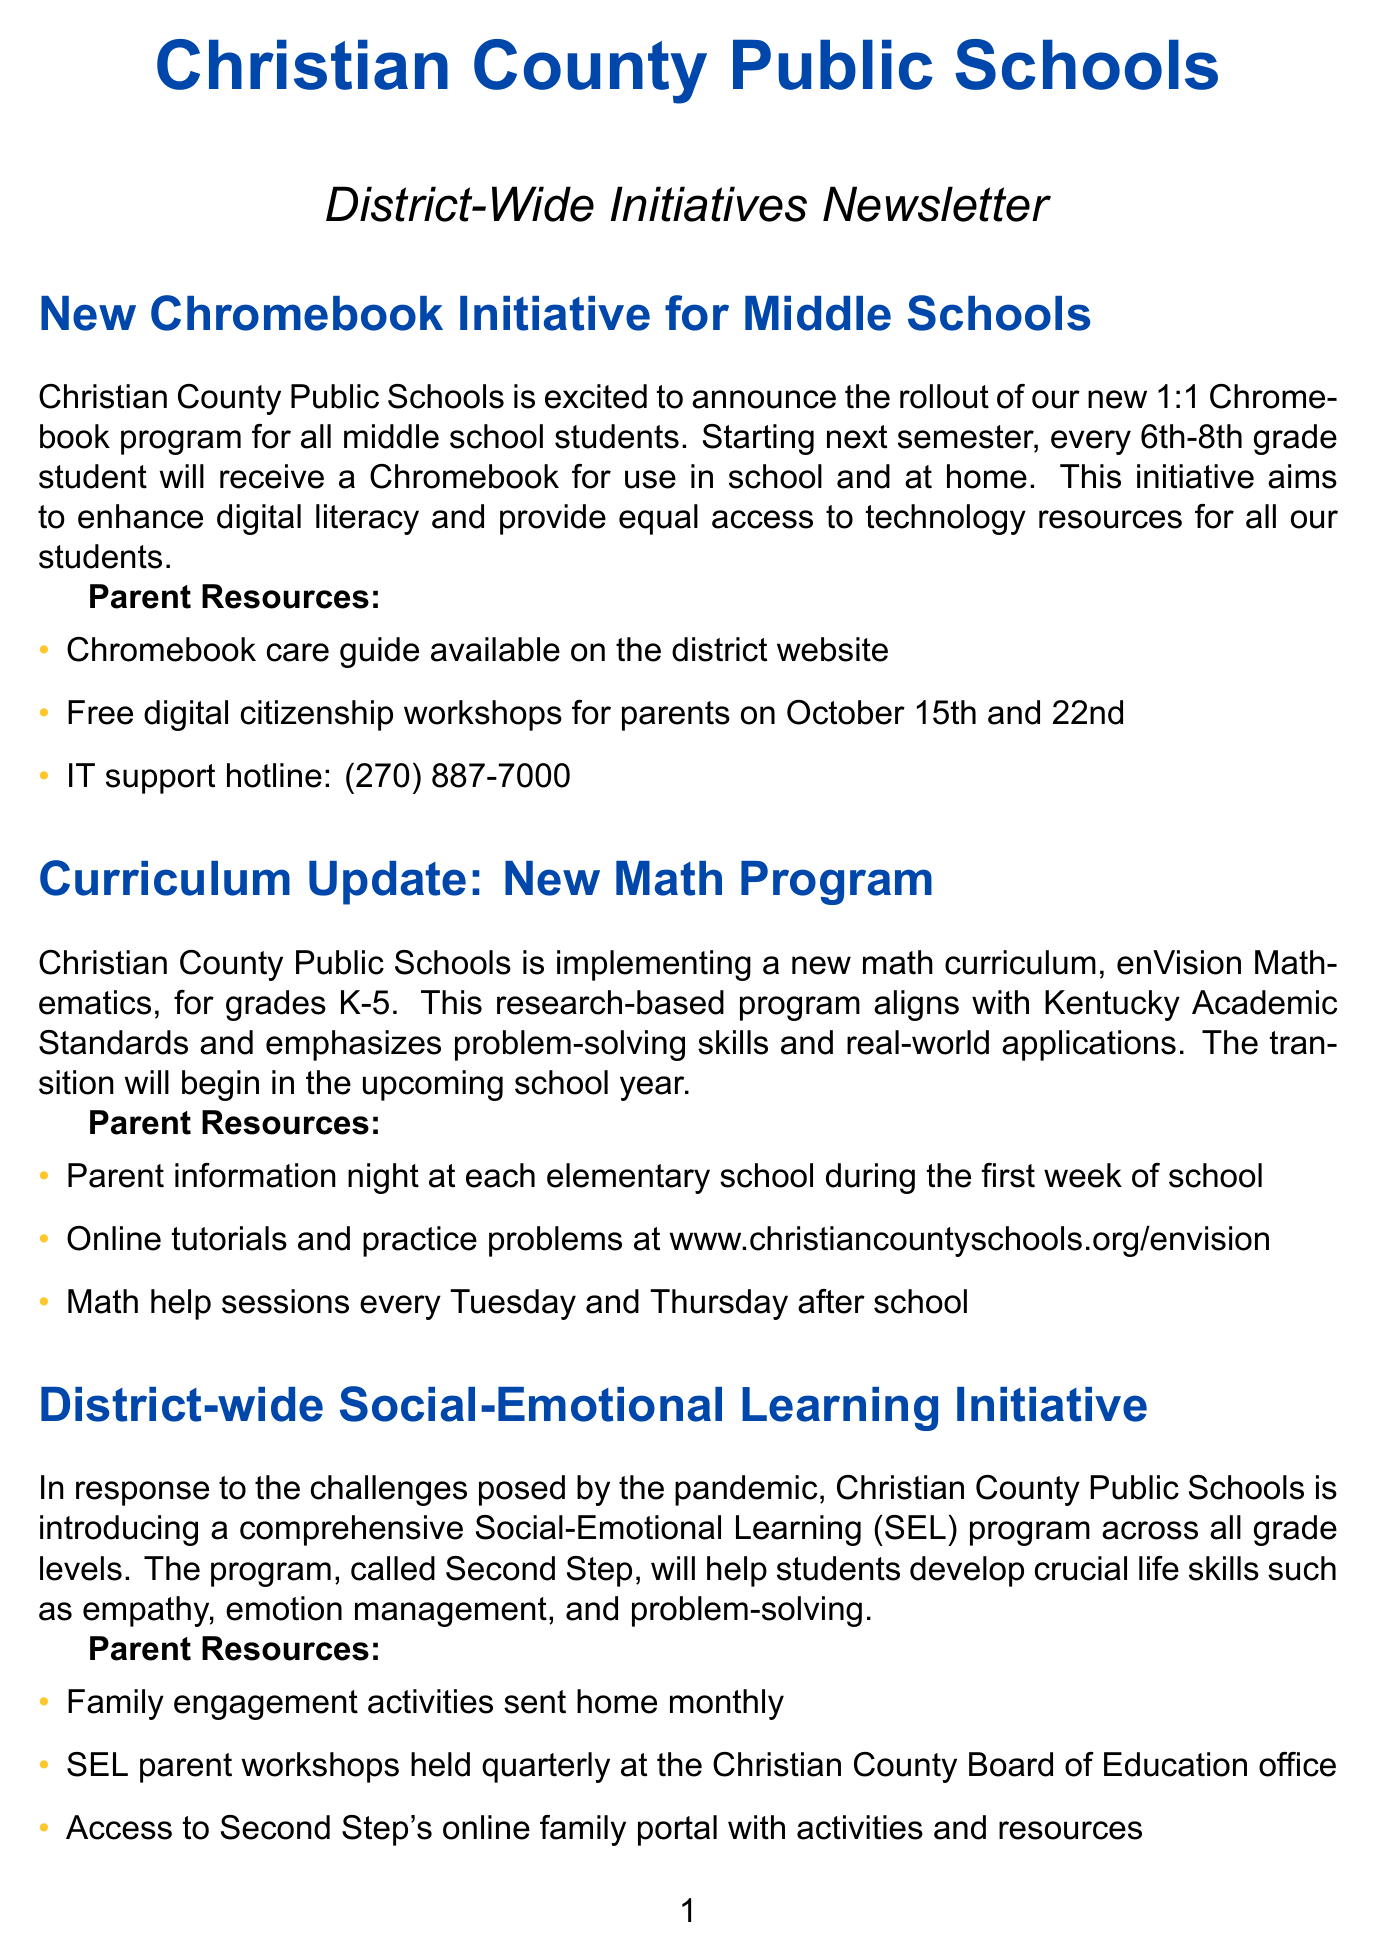what is the new technology initiative for middle schools? The initiative is a 1:1 Chromebook program for all middle school students.
Answer: 1:1 Chromebook program when will the Chromebook initiative begin? The Chromebook initiative will start next semester.
Answer: next semester what is the name of the new math program for grades K-5? The new math program is called enVision Mathematics.
Answer: enVision Mathematics how many math help sessions are offered each week? Math help sessions are offered every Tuesday and Thursday after school, totaling two sessions per week.
Answer: two what is the program introduced for Social-Emotional Learning? The program is called Second Step.
Answer: Second Step when is the dual credit information night scheduled? The dual credit information night is scheduled for September 8th.
Answer: September 8th what resource is available for parent digital citizenship training? Free digital citizenship workshops are available for parents.
Answer: Free digital citizenship workshops what is the hotline number for IT support? The IT support hotline number is (270) 887-7000.
Answer: (270) 887-7000 what guides are available to parents regarding emergency procedures? An updated emergency procedures guide is available on the district website.
Answer: updated emergency procedures guide 